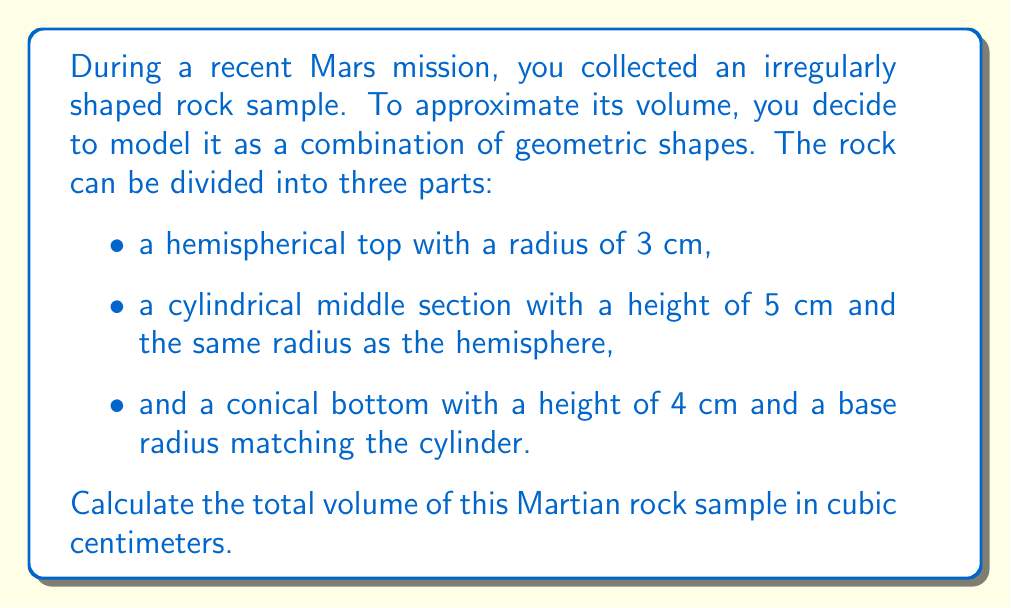Teach me how to tackle this problem. Let's break this down step-by-step:

1) First, let's calculate the volume of the hemispherical top:
   Volume of a hemisphere = $\frac{2}{3}\pi r^3$
   $V_{hemisphere} = \frac{2}{3}\pi (3\text{ cm})^3 = 18\pi \text{ cm}^3$

2) Next, let's calculate the volume of the cylindrical middle section:
   Volume of a cylinder = $\pi r^2 h$
   $V_{cylinder} = \pi (3\text{ cm})^2 (5\text{ cm}) = 45\pi \text{ cm}^3$

3) Finally, let's calculate the volume of the conical bottom:
   Volume of a cone = $\frac{1}{3}\pi r^2 h$
   $V_{cone} = \frac{1}{3}\pi (3\text{ cm})^2 (4\text{ cm}) = 12\pi \text{ cm}^3$

4) Now, we sum up all three volumes:
   $V_{total} = V_{hemisphere} + V_{cylinder} + V_{cone}$
   $V_{total} = 18\pi \text{ cm}^3 + 45\pi \text{ cm}^3 + 12\pi \text{ cm}^3$
   $V_{total} = 75\pi \text{ cm}^3$

5) To get the final numerical value, we multiply by π:
   $V_{total} = 75 * 3.14159... \approx 235.62 \text{ cm}^3$

Therefore, the approximate volume of the Martian rock sample is 235.62 cubic centimeters.
Answer: $235.62 \text{ cm}^3$ 